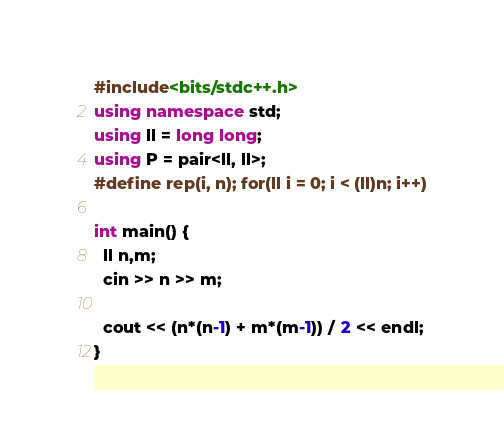<code> <loc_0><loc_0><loc_500><loc_500><_C++_>#include<bits/stdc++.h>
using namespace std;
using ll = long long;
using P = pair<ll, ll>;
#define rep(i, n); for(ll i = 0; i < (ll)n; i++)

int main() {
  ll n,m;
  cin >> n >> m;
  
  cout << (n*(n-1) + m*(m-1)) / 2 << endl;
}</code> 